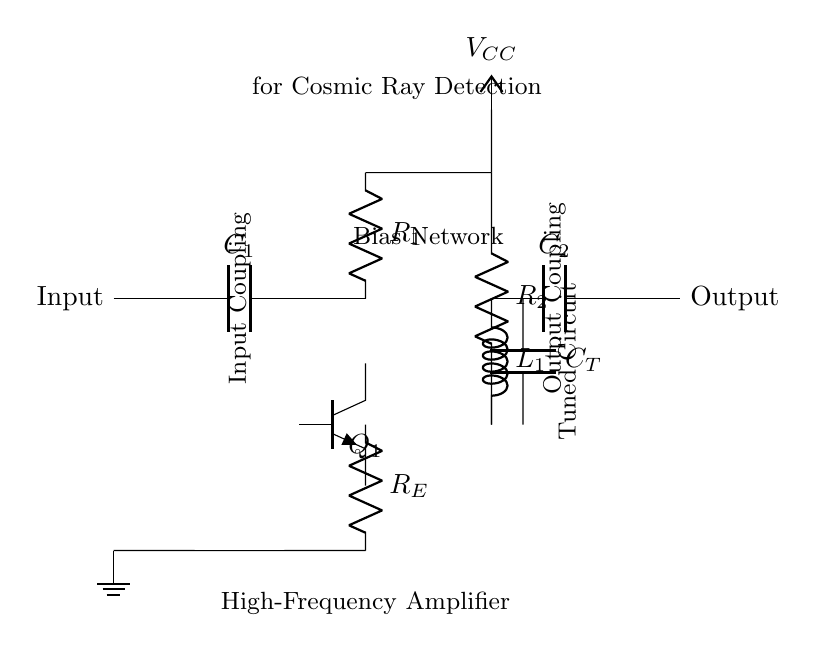What type of transistor is used in this circuit? The circuit diagram indicates an NPN transistor, shown by the symbol and typically used for amplifying signals. The label for the transistor is Q1, which confirms its role as an amplifier.
Answer: NPN What are the values of the coupling capacitors? The circuit shows two coupling capacitors, C1 and C2. Neither has a specified value visually, but they serve the purpose of coupling AC signals while blocking DC. In practice, values are chosen based on the frequency response needed.
Answer: Not specified What is the purpose of the resistor R1 in this circuit? Resistor R1 is part of the biasing network for the transistor's base. It helps set the proper operating point of the transistor, ensuring that it functions efficiently.
Answer: Biasing How is the output of this circuit coupled? The output coupling is achieved through capacitor C2, which allows AC signals to pass while preventing DC from affecting the next stage of the circuit. The output is connected directly to C2 to ensure clean signal transmission.
Answer: Through C2 What frequency is this circuit tuned for? The tuned circuit is composed of an inductor L1 and a capacitor CT, which together determine the resonant frequency. The specific frequency is often set based on the expected cosmic ray signal, not explicitly provided in the diagram.
Answer: Cosmic ray frequency (not specified) What is the role of the resistor RE in this amplifier circuit? Resistor RE is the emitter resistor, which provides stability to the amplification by helping set the emitter current and improving linearity in the amplification process. It also affects the gain of the transistor in this design.
Answer: Stability What does the symbol VCC represent in the circuit? VCC represents the positive power supply voltage in this circuit, which is necessary for powering the active components, particularly the transistor to amplify signals detected from cosmic radiation.
Answer: Positive power supply 